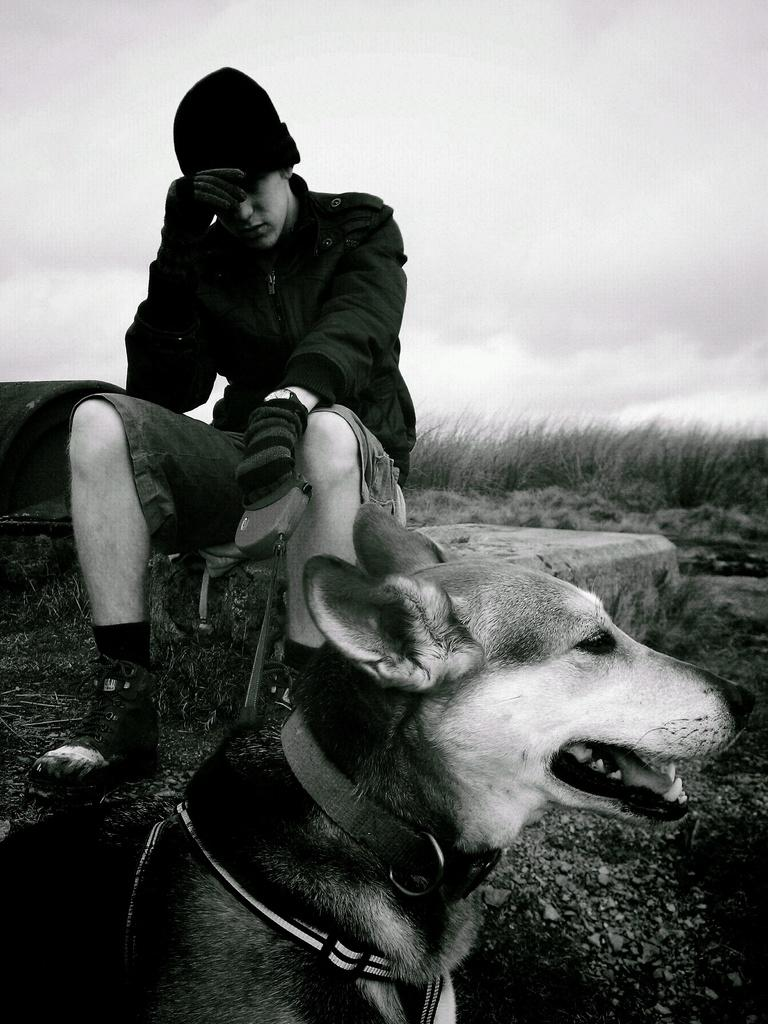What is the main subject in the center of the image? There is a dog in the center of the image. Can you describe the position of the dog in the image? The dog is in the front. What else can be seen in the background of the image? There is a man sitting in the background of the image, and dry grass is present. How would you describe the weather based on the image? The sky is cloudy in the image. What type of pollution can be seen in the image? There is no pollution visible in the image. Can you identify any insects in the image? There are no insects present in the image. 